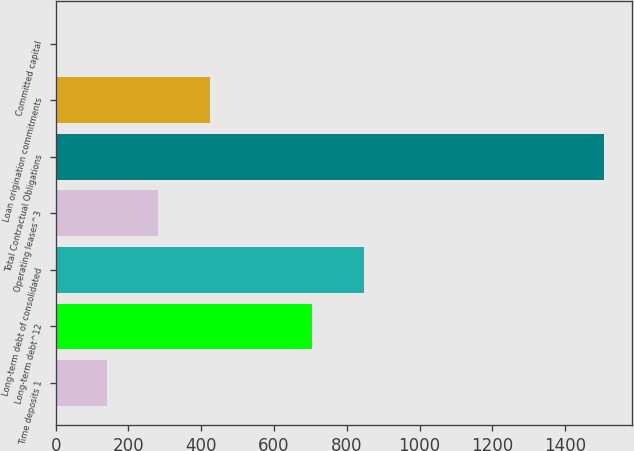<chart> <loc_0><loc_0><loc_500><loc_500><bar_chart><fcel>Time deposits 1<fcel>Long-term debt^12<fcel>Long-term debt of consolidated<fcel>Operating leases^3<fcel>Total Contractual Obligations<fcel>Loan origination commitments<fcel>Committed capital<nl><fcel>141.18<fcel>705.1<fcel>846.08<fcel>282.16<fcel>1507.48<fcel>423.14<fcel>0.2<nl></chart> 